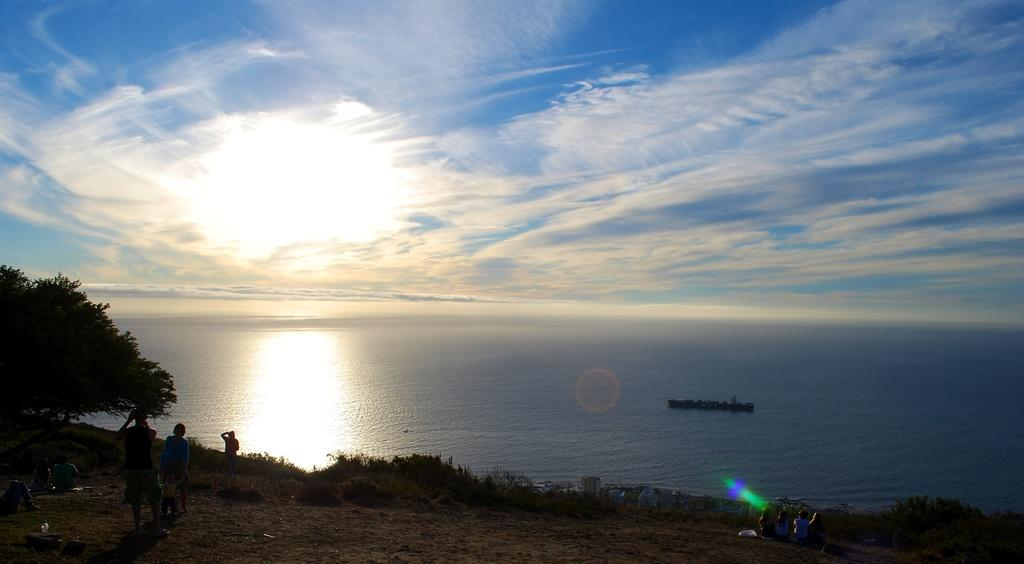What is the person in the image standing on? The person is standing on the ground in the image. What type of vegetation can be seen in the image? There is a tree and grass in the image. What natural element is present in the image? There is water in the image. What is visible in the sky in the image? The sky and the sun are visible in the image. What route does the ice follow in the image? There is no ice present in the image, so it is not possible to determine a route for it. 